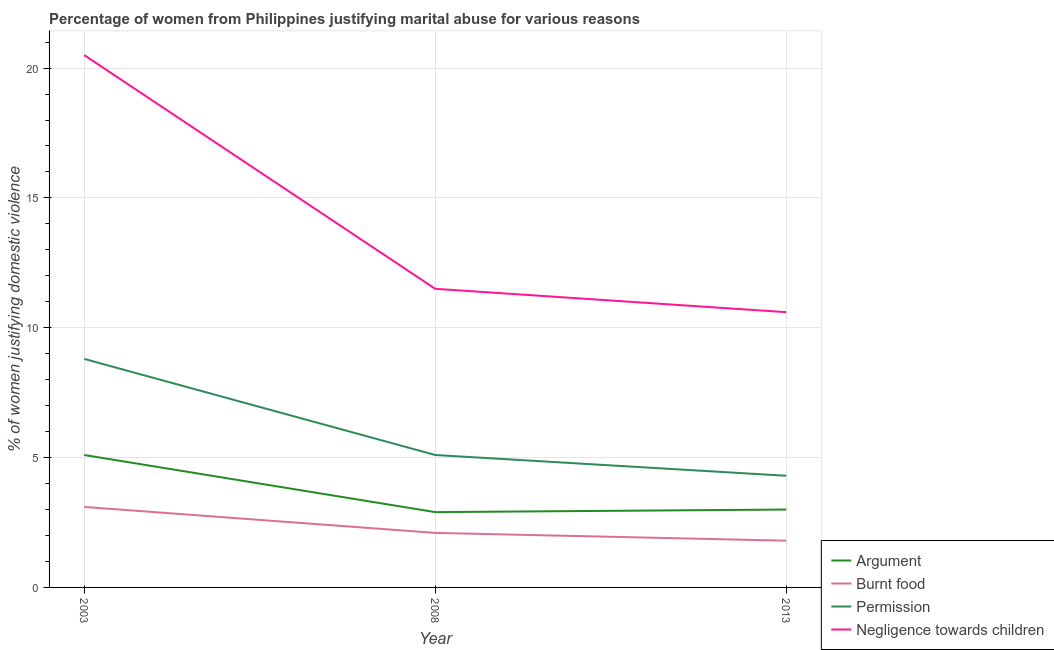What is the difference between the percentage of women justifying abuse for burning food in 2003 and the percentage of women justifying abuse in the case of an argument in 2013?
Keep it short and to the point. 0.1. What is the average percentage of women justifying abuse for burning food per year?
Your answer should be very brief. 2.33. In the year 2013, what is the difference between the percentage of women justifying abuse for going without permission and percentage of women justifying abuse for burning food?
Provide a succinct answer. 2.5. In how many years, is the percentage of women justifying abuse for burning food greater than 19 %?
Keep it short and to the point. 0. What is the ratio of the percentage of women justifying abuse for going without permission in 2003 to that in 2008?
Keep it short and to the point. 1.73. Is the difference between the percentage of women justifying abuse for burning food in 2008 and 2013 greater than the difference between the percentage of women justifying abuse in the case of an argument in 2008 and 2013?
Your answer should be compact. Yes. What is the difference between the highest and the lowest percentage of women justifying abuse for burning food?
Your response must be concise. 1.3. In how many years, is the percentage of women justifying abuse for showing negligence towards children greater than the average percentage of women justifying abuse for showing negligence towards children taken over all years?
Provide a short and direct response. 1. Is it the case that in every year, the sum of the percentage of women justifying abuse in the case of an argument and percentage of women justifying abuse for burning food is greater than the percentage of women justifying abuse for going without permission?
Your answer should be compact. No. Is the percentage of women justifying abuse for burning food strictly greater than the percentage of women justifying abuse in the case of an argument over the years?
Ensure brevity in your answer.  No. Is the percentage of women justifying abuse in the case of an argument strictly less than the percentage of women justifying abuse for burning food over the years?
Your response must be concise. No. Where does the legend appear in the graph?
Your answer should be compact. Bottom right. How many legend labels are there?
Provide a short and direct response. 4. What is the title of the graph?
Offer a very short reply. Percentage of women from Philippines justifying marital abuse for various reasons. Does "Grants and Revenue" appear as one of the legend labels in the graph?
Offer a terse response. No. What is the label or title of the Y-axis?
Your answer should be compact. % of women justifying domestic violence. What is the % of women justifying domestic violence of Permission in 2003?
Keep it short and to the point. 8.8. What is the % of women justifying domestic violence in Negligence towards children in 2003?
Provide a short and direct response. 20.5. What is the % of women justifying domestic violence in Burnt food in 2008?
Make the answer very short. 2.1. What is the % of women justifying domestic violence of Permission in 2008?
Offer a very short reply. 5.1. What is the % of women justifying domestic violence of Negligence towards children in 2008?
Your response must be concise. 11.5. What is the % of women justifying domestic violence of Burnt food in 2013?
Offer a terse response. 1.8. What is the % of women justifying domestic violence in Negligence towards children in 2013?
Make the answer very short. 10.6. Across all years, what is the maximum % of women justifying domestic violence in Argument?
Provide a short and direct response. 5.1. Across all years, what is the minimum % of women justifying domestic violence of Argument?
Keep it short and to the point. 2.9. Across all years, what is the minimum % of women justifying domestic violence in Burnt food?
Your answer should be compact. 1.8. Across all years, what is the minimum % of women justifying domestic violence in Permission?
Offer a terse response. 4.3. What is the total % of women justifying domestic violence of Permission in the graph?
Offer a very short reply. 18.2. What is the total % of women justifying domestic violence in Negligence towards children in the graph?
Give a very brief answer. 42.6. What is the difference between the % of women justifying domestic violence of Argument in 2003 and that in 2008?
Your response must be concise. 2.2. What is the difference between the % of women justifying domestic violence of Burnt food in 2003 and that in 2008?
Your answer should be very brief. 1. What is the difference between the % of women justifying domestic violence in Negligence towards children in 2003 and that in 2008?
Keep it short and to the point. 9. What is the difference between the % of women justifying domestic violence in Argument in 2003 and that in 2013?
Ensure brevity in your answer.  2.1. What is the difference between the % of women justifying domestic violence of Permission in 2003 and that in 2013?
Your answer should be compact. 4.5. What is the difference between the % of women justifying domestic violence of Negligence towards children in 2003 and that in 2013?
Make the answer very short. 9.9. What is the difference between the % of women justifying domestic violence of Argument in 2008 and that in 2013?
Offer a terse response. -0.1. What is the difference between the % of women justifying domestic violence in Permission in 2008 and that in 2013?
Your answer should be very brief. 0.8. What is the difference between the % of women justifying domestic violence in Negligence towards children in 2008 and that in 2013?
Your response must be concise. 0.9. What is the difference between the % of women justifying domestic violence of Argument in 2003 and the % of women justifying domestic violence of Burnt food in 2008?
Provide a short and direct response. 3. What is the difference between the % of women justifying domestic violence in Argument in 2003 and the % of women justifying domestic violence in Permission in 2008?
Give a very brief answer. 0. What is the difference between the % of women justifying domestic violence of Burnt food in 2003 and the % of women justifying domestic violence of Permission in 2008?
Offer a terse response. -2. What is the difference between the % of women justifying domestic violence of Burnt food in 2003 and the % of women justifying domestic violence of Negligence towards children in 2008?
Keep it short and to the point. -8.4. What is the difference between the % of women justifying domestic violence in Argument in 2003 and the % of women justifying domestic violence in Permission in 2013?
Ensure brevity in your answer.  0.8. What is the difference between the % of women justifying domestic violence of Permission in 2003 and the % of women justifying domestic violence of Negligence towards children in 2013?
Your answer should be compact. -1.8. What is the difference between the % of women justifying domestic violence of Argument in 2008 and the % of women justifying domestic violence of Burnt food in 2013?
Your answer should be very brief. 1.1. What is the difference between the % of women justifying domestic violence of Argument in 2008 and the % of women justifying domestic violence of Permission in 2013?
Provide a succinct answer. -1.4. What is the difference between the % of women justifying domestic violence in Burnt food in 2008 and the % of women justifying domestic violence in Permission in 2013?
Give a very brief answer. -2.2. What is the average % of women justifying domestic violence of Argument per year?
Keep it short and to the point. 3.67. What is the average % of women justifying domestic violence in Burnt food per year?
Make the answer very short. 2.33. What is the average % of women justifying domestic violence in Permission per year?
Your answer should be compact. 6.07. In the year 2003, what is the difference between the % of women justifying domestic violence in Argument and % of women justifying domestic violence in Burnt food?
Provide a succinct answer. 2. In the year 2003, what is the difference between the % of women justifying domestic violence of Argument and % of women justifying domestic violence of Negligence towards children?
Your response must be concise. -15.4. In the year 2003, what is the difference between the % of women justifying domestic violence of Burnt food and % of women justifying domestic violence of Negligence towards children?
Make the answer very short. -17.4. In the year 2008, what is the difference between the % of women justifying domestic violence of Argument and % of women justifying domestic violence of Burnt food?
Keep it short and to the point. 0.8. In the year 2008, what is the difference between the % of women justifying domestic violence of Argument and % of women justifying domestic violence of Negligence towards children?
Your response must be concise. -8.6. In the year 2008, what is the difference between the % of women justifying domestic violence of Burnt food and % of women justifying domestic violence of Permission?
Offer a terse response. -3. In the year 2013, what is the difference between the % of women justifying domestic violence of Argument and % of women justifying domestic violence of Permission?
Your response must be concise. -1.3. In the year 2013, what is the difference between the % of women justifying domestic violence of Argument and % of women justifying domestic violence of Negligence towards children?
Offer a terse response. -7.6. What is the ratio of the % of women justifying domestic violence of Argument in 2003 to that in 2008?
Give a very brief answer. 1.76. What is the ratio of the % of women justifying domestic violence in Burnt food in 2003 to that in 2008?
Keep it short and to the point. 1.48. What is the ratio of the % of women justifying domestic violence of Permission in 2003 to that in 2008?
Ensure brevity in your answer.  1.73. What is the ratio of the % of women justifying domestic violence in Negligence towards children in 2003 to that in 2008?
Your answer should be compact. 1.78. What is the ratio of the % of women justifying domestic violence of Argument in 2003 to that in 2013?
Your response must be concise. 1.7. What is the ratio of the % of women justifying domestic violence of Burnt food in 2003 to that in 2013?
Your answer should be very brief. 1.72. What is the ratio of the % of women justifying domestic violence in Permission in 2003 to that in 2013?
Offer a terse response. 2.05. What is the ratio of the % of women justifying domestic violence in Negligence towards children in 2003 to that in 2013?
Make the answer very short. 1.93. What is the ratio of the % of women justifying domestic violence of Argument in 2008 to that in 2013?
Offer a terse response. 0.97. What is the ratio of the % of women justifying domestic violence of Permission in 2008 to that in 2013?
Provide a short and direct response. 1.19. What is the ratio of the % of women justifying domestic violence in Negligence towards children in 2008 to that in 2013?
Your response must be concise. 1.08. What is the difference between the highest and the second highest % of women justifying domestic violence of Permission?
Your answer should be very brief. 3.7. What is the difference between the highest and the lowest % of women justifying domestic violence of Permission?
Offer a very short reply. 4.5. What is the difference between the highest and the lowest % of women justifying domestic violence of Negligence towards children?
Your answer should be very brief. 9.9. 